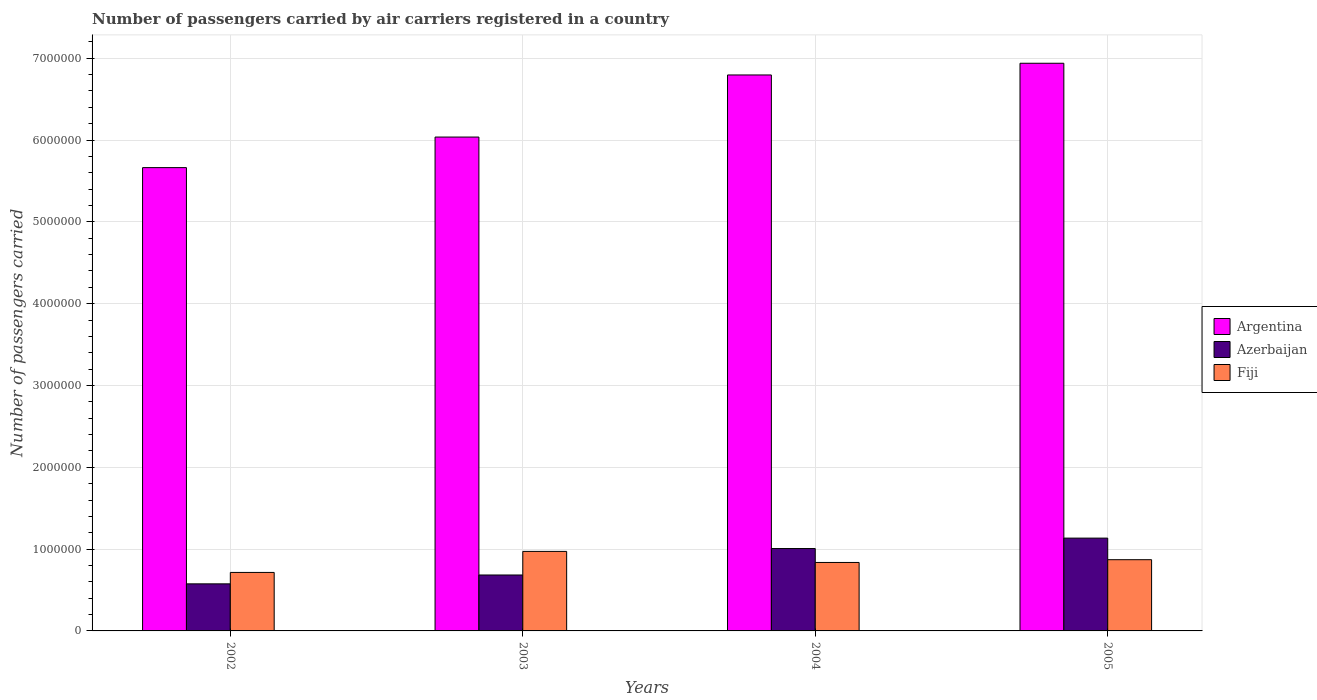How many different coloured bars are there?
Offer a terse response. 3. How many groups of bars are there?
Offer a very short reply. 4. Are the number of bars on each tick of the X-axis equal?
Offer a terse response. Yes. How many bars are there on the 1st tick from the right?
Offer a terse response. 3. What is the number of passengers carried by air carriers in Azerbaijan in 2002?
Ensure brevity in your answer.  5.75e+05. Across all years, what is the maximum number of passengers carried by air carriers in Fiji?
Provide a short and direct response. 9.72e+05. Across all years, what is the minimum number of passengers carried by air carriers in Fiji?
Your answer should be compact. 7.15e+05. In which year was the number of passengers carried by air carriers in Azerbaijan minimum?
Your answer should be very brief. 2002. What is the total number of passengers carried by air carriers in Argentina in the graph?
Offer a very short reply. 2.54e+07. What is the difference between the number of passengers carried by air carriers in Fiji in 2004 and that in 2005?
Give a very brief answer. -3.39e+04. What is the difference between the number of passengers carried by air carriers in Fiji in 2003 and the number of passengers carried by air carriers in Azerbaijan in 2002?
Provide a short and direct response. 3.97e+05. What is the average number of passengers carried by air carriers in Fiji per year?
Offer a terse response. 8.49e+05. In the year 2003, what is the difference between the number of passengers carried by air carriers in Azerbaijan and number of passengers carried by air carriers in Fiji?
Ensure brevity in your answer.  -2.88e+05. What is the ratio of the number of passengers carried by air carriers in Argentina in 2004 to that in 2005?
Provide a short and direct response. 0.98. Is the number of passengers carried by air carriers in Azerbaijan in 2002 less than that in 2003?
Give a very brief answer. Yes. Is the difference between the number of passengers carried by air carriers in Azerbaijan in 2002 and 2003 greater than the difference between the number of passengers carried by air carriers in Fiji in 2002 and 2003?
Provide a succinct answer. Yes. What is the difference between the highest and the second highest number of passengers carried by air carriers in Argentina?
Keep it short and to the point. 1.43e+05. What is the difference between the highest and the lowest number of passengers carried by air carriers in Fiji?
Give a very brief answer. 2.57e+05. In how many years, is the number of passengers carried by air carriers in Argentina greater than the average number of passengers carried by air carriers in Argentina taken over all years?
Keep it short and to the point. 2. What does the 1st bar from the left in 2004 represents?
Give a very brief answer. Argentina. What does the 1st bar from the right in 2004 represents?
Offer a very short reply. Fiji. Are all the bars in the graph horizontal?
Offer a very short reply. No. How many years are there in the graph?
Offer a terse response. 4. What is the difference between two consecutive major ticks on the Y-axis?
Your answer should be compact. 1.00e+06. Does the graph contain any zero values?
Your answer should be very brief. No. Where does the legend appear in the graph?
Provide a short and direct response. Center right. How many legend labels are there?
Provide a succinct answer. 3. What is the title of the graph?
Keep it short and to the point. Number of passengers carried by air carriers registered in a country. What is the label or title of the Y-axis?
Make the answer very short. Number of passengers carried. What is the Number of passengers carried in Argentina in 2002?
Your answer should be compact. 5.66e+06. What is the Number of passengers carried in Azerbaijan in 2002?
Offer a terse response. 5.75e+05. What is the Number of passengers carried of Fiji in 2002?
Your answer should be compact. 7.15e+05. What is the Number of passengers carried of Argentina in 2003?
Keep it short and to the point. 6.04e+06. What is the Number of passengers carried in Azerbaijan in 2003?
Keep it short and to the point. 6.84e+05. What is the Number of passengers carried of Fiji in 2003?
Provide a succinct answer. 9.72e+05. What is the Number of passengers carried in Argentina in 2004?
Provide a short and direct response. 6.80e+06. What is the Number of passengers carried in Azerbaijan in 2004?
Make the answer very short. 1.01e+06. What is the Number of passengers carried of Fiji in 2004?
Offer a terse response. 8.37e+05. What is the Number of passengers carried of Argentina in 2005?
Make the answer very short. 6.94e+06. What is the Number of passengers carried in Azerbaijan in 2005?
Provide a short and direct response. 1.13e+06. What is the Number of passengers carried in Fiji in 2005?
Give a very brief answer. 8.71e+05. Across all years, what is the maximum Number of passengers carried in Argentina?
Give a very brief answer. 6.94e+06. Across all years, what is the maximum Number of passengers carried in Azerbaijan?
Your answer should be very brief. 1.13e+06. Across all years, what is the maximum Number of passengers carried in Fiji?
Your response must be concise. 9.72e+05. Across all years, what is the minimum Number of passengers carried of Argentina?
Make the answer very short. 5.66e+06. Across all years, what is the minimum Number of passengers carried of Azerbaijan?
Provide a short and direct response. 5.75e+05. Across all years, what is the minimum Number of passengers carried in Fiji?
Offer a terse response. 7.15e+05. What is the total Number of passengers carried of Argentina in the graph?
Your answer should be very brief. 2.54e+07. What is the total Number of passengers carried of Azerbaijan in the graph?
Offer a terse response. 3.40e+06. What is the total Number of passengers carried in Fiji in the graph?
Provide a succinct answer. 3.39e+06. What is the difference between the Number of passengers carried of Argentina in 2002 and that in 2003?
Offer a very short reply. -3.73e+05. What is the difference between the Number of passengers carried in Azerbaijan in 2002 and that in 2003?
Your answer should be compact. -1.08e+05. What is the difference between the Number of passengers carried of Fiji in 2002 and that in 2003?
Provide a succinct answer. -2.57e+05. What is the difference between the Number of passengers carried of Argentina in 2002 and that in 2004?
Provide a succinct answer. -1.13e+06. What is the difference between the Number of passengers carried of Azerbaijan in 2002 and that in 2004?
Your response must be concise. -4.32e+05. What is the difference between the Number of passengers carried of Fiji in 2002 and that in 2004?
Your answer should be very brief. -1.22e+05. What is the difference between the Number of passengers carried of Argentina in 2002 and that in 2005?
Your answer should be compact. -1.28e+06. What is the difference between the Number of passengers carried of Azerbaijan in 2002 and that in 2005?
Your answer should be very brief. -5.59e+05. What is the difference between the Number of passengers carried of Fiji in 2002 and that in 2005?
Your response must be concise. -1.56e+05. What is the difference between the Number of passengers carried of Argentina in 2003 and that in 2004?
Offer a very short reply. -7.59e+05. What is the difference between the Number of passengers carried of Azerbaijan in 2003 and that in 2004?
Make the answer very short. -3.23e+05. What is the difference between the Number of passengers carried of Fiji in 2003 and that in 2004?
Your response must be concise. 1.35e+05. What is the difference between the Number of passengers carried of Argentina in 2003 and that in 2005?
Your response must be concise. -9.02e+05. What is the difference between the Number of passengers carried in Azerbaijan in 2003 and that in 2005?
Your answer should be very brief. -4.51e+05. What is the difference between the Number of passengers carried of Fiji in 2003 and that in 2005?
Your answer should be compact. 1.01e+05. What is the difference between the Number of passengers carried of Argentina in 2004 and that in 2005?
Your response must be concise. -1.43e+05. What is the difference between the Number of passengers carried of Azerbaijan in 2004 and that in 2005?
Offer a terse response. -1.27e+05. What is the difference between the Number of passengers carried in Fiji in 2004 and that in 2005?
Offer a very short reply. -3.39e+04. What is the difference between the Number of passengers carried in Argentina in 2002 and the Number of passengers carried in Azerbaijan in 2003?
Your answer should be compact. 4.98e+06. What is the difference between the Number of passengers carried in Argentina in 2002 and the Number of passengers carried in Fiji in 2003?
Provide a short and direct response. 4.69e+06. What is the difference between the Number of passengers carried in Azerbaijan in 2002 and the Number of passengers carried in Fiji in 2003?
Your answer should be very brief. -3.97e+05. What is the difference between the Number of passengers carried of Argentina in 2002 and the Number of passengers carried of Azerbaijan in 2004?
Provide a short and direct response. 4.66e+06. What is the difference between the Number of passengers carried of Argentina in 2002 and the Number of passengers carried of Fiji in 2004?
Give a very brief answer. 4.83e+06. What is the difference between the Number of passengers carried of Azerbaijan in 2002 and the Number of passengers carried of Fiji in 2004?
Ensure brevity in your answer.  -2.61e+05. What is the difference between the Number of passengers carried in Argentina in 2002 and the Number of passengers carried in Azerbaijan in 2005?
Your answer should be compact. 4.53e+06. What is the difference between the Number of passengers carried in Argentina in 2002 and the Number of passengers carried in Fiji in 2005?
Make the answer very short. 4.79e+06. What is the difference between the Number of passengers carried in Azerbaijan in 2002 and the Number of passengers carried in Fiji in 2005?
Ensure brevity in your answer.  -2.95e+05. What is the difference between the Number of passengers carried in Argentina in 2003 and the Number of passengers carried in Azerbaijan in 2004?
Offer a terse response. 5.03e+06. What is the difference between the Number of passengers carried in Argentina in 2003 and the Number of passengers carried in Fiji in 2004?
Your answer should be very brief. 5.20e+06. What is the difference between the Number of passengers carried in Azerbaijan in 2003 and the Number of passengers carried in Fiji in 2004?
Give a very brief answer. -1.53e+05. What is the difference between the Number of passengers carried of Argentina in 2003 and the Number of passengers carried of Azerbaijan in 2005?
Ensure brevity in your answer.  4.90e+06. What is the difference between the Number of passengers carried in Argentina in 2003 and the Number of passengers carried in Fiji in 2005?
Your answer should be very brief. 5.17e+06. What is the difference between the Number of passengers carried of Azerbaijan in 2003 and the Number of passengers carried of Fiji in 2005?
Make the answer very short. -1.87e+05. What is the difference between the Number of passengers carried in Argentina in 2004 and the Number of passengers carried in Azerbaijan in 2005?
Make the answer very short. 5.66e+06. What is the difference between the Number of passengers carried of Argentina in 2004 and the Number of passengers carried of Fiji in 2005?
Your response must be concise. 5.92e+06. What is the difference between the Number of passengers carried in Azerbaijan in 2004 and the Number of passengers carried in Fiji in 2005?
Offer a terse response. 1.36e+05. What is the average Number of passengers carried in Argentina per year?
Keep it short and to the point. 6.36e+06. What is the average Number of passengers carried of Azerbaijan per year?
Your answer should be very brief. 8.50e+05. What is the average Number of passengers carried in Fiji per year?
Ensure brevity in your answer.  8.49e+05. In the year 2002, what is the difference between the Number of passengers carried in Argentina and Number of passengers carried in Azerbaijan?
Your response must be concise. 5.09e+06. In the year 2002, what is the difference between the Number of passengers carried of Argentina and Number of passengers carried of Fiji?
Provide a short and direct response. 4.95e+06. In the year 2002, what is the difference between the Number of passengers carried in Azerbaijan and Number of passengers carried in Fiji?
Your answer should be compact. -1.40e+05. In the year 2003, what is the difference between the Number of passengers carried in Argentina and Number of passengers carried in Azerbaijan?
Ensure brevity in your answer.  5.35e+06. In the year 2003, what is the difference between the Number of passengers carried of Argentina and Number of passengers carried of Fiji?
Keep it short and to the point. 5.06e+06. In the year 2003, what is the difference between the Number of passengers carried of Azerbaijan and Number of passengers carried of Fiji?
Your answer should be compact. -2.88e+05. In the year 2004, what is the difference between the Number of passengers carried in Argentina and Number of passengers carried in Azerbaijan?
Your response must be concise. 5.79e+06. In the year 2004, what is the difference between the Number of passengers carried in Argentina and Number of passengers carried in Fiji?
Provide a succinct answer. 5.96e+06. In the year 2004, what is the difference between the Number of passengers carried of Azerbaijan and Number of passengers carried of Fiji?
Offer a very short reply. 1.70e+05. In the year 2005, what is the difference between the Number of passengers carried in Argentina and Number of passengers carried in Azerbaijan?
Make the answer very short. 5.80e+06. In the year 2005, what is the difference between the Number of passengers carried in Argentina and Number of passengers carried in Fiji?
Make the answer very short. 6.07e+06. In the year 2005, what is the difference between the Number of passengers carried in Azerbaijan and Number of passengers carried in Fiji?
Your response must be concise. 2.64e+05. What is the ratio of the Number of passengers carried in Argentina in 2002 to that in 2003?
Keep it short and to the point. 0.94. What is the ratio of the Number of passengers carried of Azerbaijan in 2002 to that in 2003?
Keep it short and to the point. 0.84. What is the ratio of the Number of passengers carried of Fiji in 2002 to that in 2003?
Provide a succinct answer. 0.74. What is the ratio of the Number of passengers carried in Azerbaijan in 2002 to that in 2004?
Your answer should be compact. 0.57. What is the ratio of the Number of passengers carried in Fiji in 2002 to that in 2004?
Provide a succinct answer. 0.85. What is the ratio of the Number of passengers carried in Argentina in 2002 to that in 2005?
Ensure brevity in your answer.  0.82. What is the ratio of the Number of passengers carried of Azerbaijan in 2002 to that in 2005?
Provide a succinct answer. 0.51. What is the ratio of the Number of passengers carried of Fiji in 2002 to that in 2005?
Provide a succinct answer. 0.82. What is the ratio of the Number of passengers carried in Argentina in 2003 to that in 2004?
Provide a short and direct response. 0.89. What is the ratio of the Number of passengers carried in Azerbaijan in 2003 to that in 2004?
Your answer should be very brief. 0.68. What is the ratio of the Number of passengers carried of Fiji in 2003 to that in 2004?
Keep it short and to the point. 1.16. What is the ratio of the Number of passengers carried of Argentina in 2003 to that in 2005?
Provide a short and direct response. 0.87. What is the ratio of the Number of passengers carried in Azerbaijan in 2003 to that in 2005?
Provide a short and direct response. 0.6. What is the ratio of the Number of passengers carried in Fiji in 2003 to that in 2005?
Ensure brevity in your answer.  1.12. What is the ratio of the Number of passengers carried in Argentina in 2004 to that in 2005?
Provide a short and direct response. 0.98. What is the ratio of the Number of passengers carried of Azerbaijan in 2004 to that in 2005?
Provide a succinct answer. 0.89. What is the ratio of the Number of passengers carried in Fiji in 2004 to that in 2005?
Your response must be concise. 0.96. What is the difference between the highest and the second highest Number of passengers carried of Argentina?
Your answer should be compact. 1.43e+05. What is the difference between the highest and the second highest Number of passengers carried in Azerbaijan?
Offer a terse response. 1.27e+05. What is the difference between the highest and the second highest Number of passengers carried of Fiji?
Your response must be concise. 1.01e+05. What is the difference between the highest and the lowest Number of passengers carried of Argentina?
Keep it short and to the point. 1.28e+06. What is the difference between the highest and the lowest Number of passengers carried of Azerbaijan?
Your answer should be compact. 5.59e+05. What is the difference between the highest and the lowest Number of passengers carried in Fiji?
Ensure brevity in your answer.  2.57e+05. 